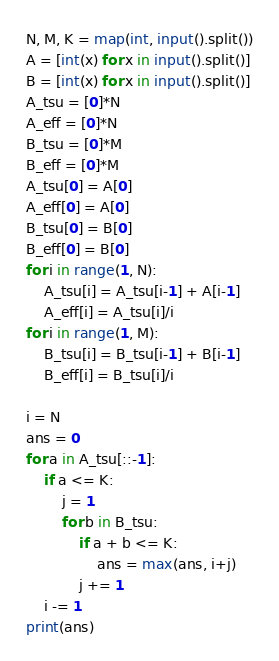Convert code to text. <code><loc_0><loc_0><loc_500><loc_500><_Python_>N, M, K = map(int, input().split())
A = [int(x) for x in input().split()]
B = [int(x) for x in input().split()]
A_tsu = [0]*N
A_eff = [0]*N
B_tsu = [0]*M
B_eff = [0]*M
A_tsu[0] = A[0]
A_eff[0] = A[0]
B_tsu[0] = B[0]
B_eff[0] = B[0]
for i in range(1, N):
    A_tsu[i] = A_tsu[i-1] + A[i-1]
    A_eff[i] = A_tsu[i]/i
for i in range(1, M):
    B_tsu[i] = B_tsu[i-1] + B[i-1]
    B_eff[i] = B_tsu[i]/i

i = N
ans = 0
for a in A_tsu[::-1]:
    if a <= K:
        j = 1
        for b in B_tsu:
            if a + b <= K:
                ans = max(ans, i+j)
            j += 1
    i -= 1
print(ans)
</code> 